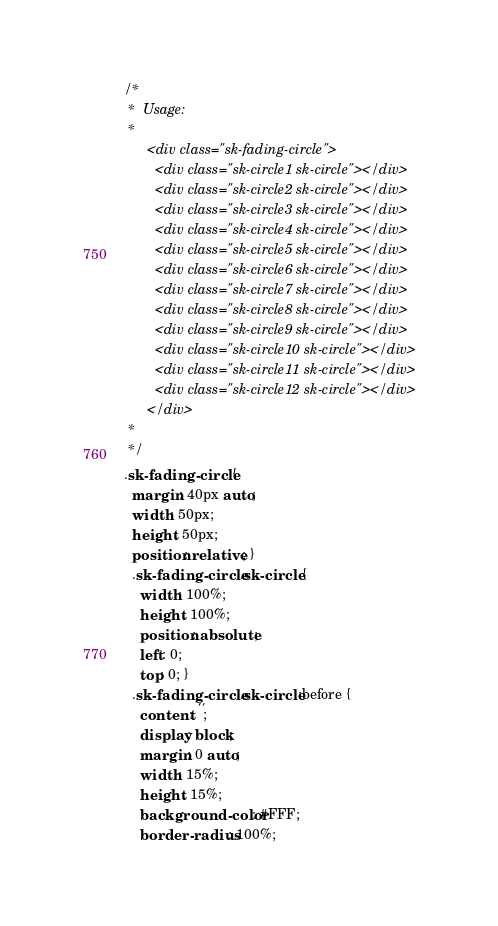<code> <loc_0><loc_0><loc_500><loc_500><_CSS_>/*
 *  Usage:
 *
      <div class="sk-fading-circle">
        <div class="sk-circle1 sk-circle"></div>
        <div class="sk-circle2 sk-circle"></div>
        <div class="sk-circle3 sk-circle"></div>
        <div class="sk-circle4 sk-circle"></div>
        <div class="sk-circle5 sk-circle"></div>
        <div class="sk-circle6 sk-circle"></div>
        <div class="sk-circle7 sk-circle"></div>
        <div class="sk-circle8 sk-circle"></div>
        <div class="sk-circle9 sk-circle"></div>
        <div class="sk-circle10 sk-circle"></div>
        <div class="sk-circle11 sk-circle"></div>
        <div class="sk-circle12 sk-circle"></div>
      </div>
 *
 */
.sk-fading-circle {
  margin: 40px auto;
  width: 50px;
  height: 50px;
  position: relative; }
  .sk-fading-circle .sk-circle {
    width: 100%;
    height: 100%;
    position: absolute;
    left: 0;
    top: 0; }
  .sk-fading-circle .sk-circle:before {
    content: '';
    display: block;
    margin: 0 auto;
    width: 15%;
    height: 15%;
    background-color: #FFF;
    border-radius: 100%;</code> 